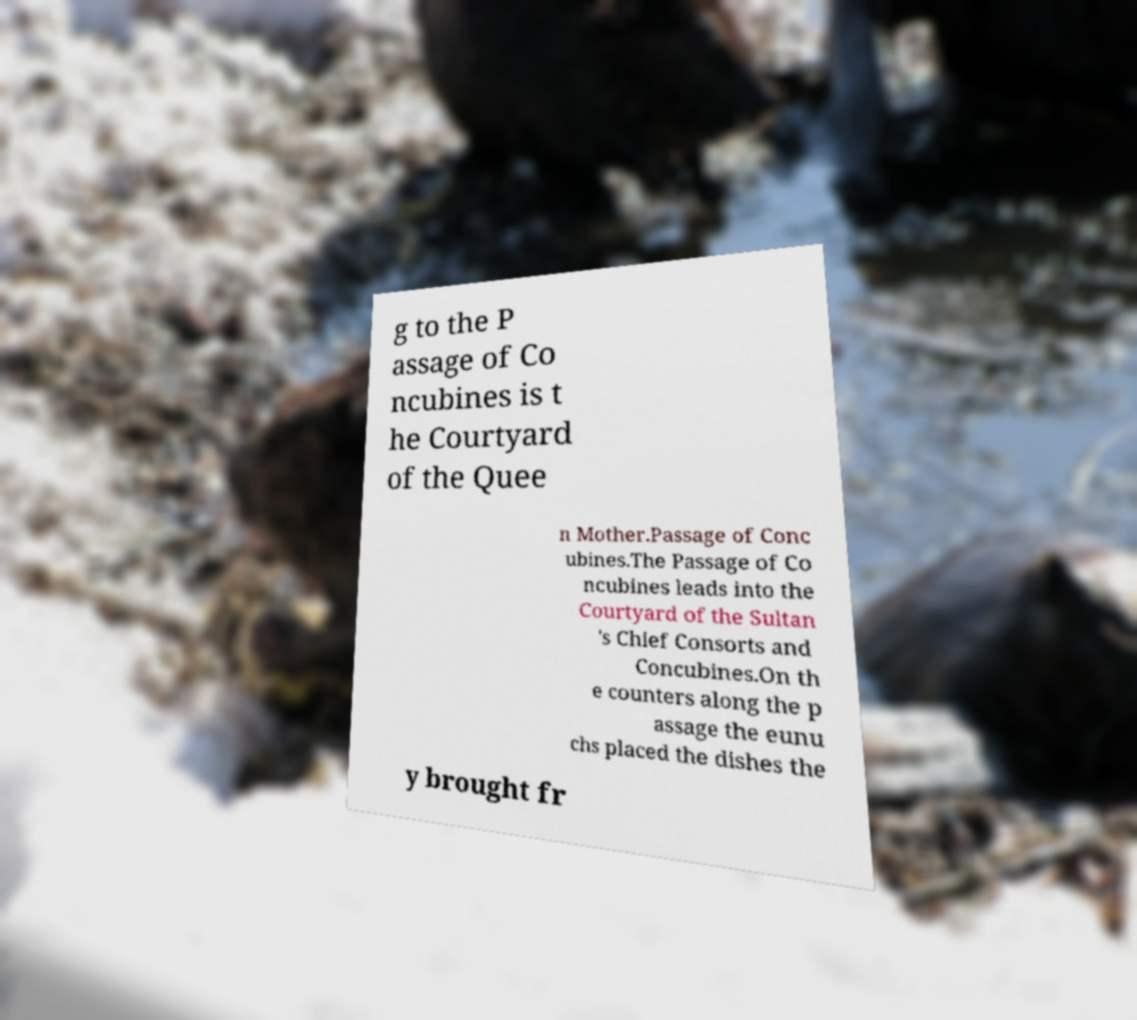Can you read and provide the text displayed in the image?This photo seems to have some interesting text. Can you extract and type it out for me? g to the P assage of Co ncubines is t he Courtyard of the Quee n Mother.Passage of Conc ubines.The Passage of Co ncubines leads into the Courtyard of the Sultan 's Chief Consorts and Concubines.On th e counters along the p assage the eunu chs placed the dishes the y brought fr 